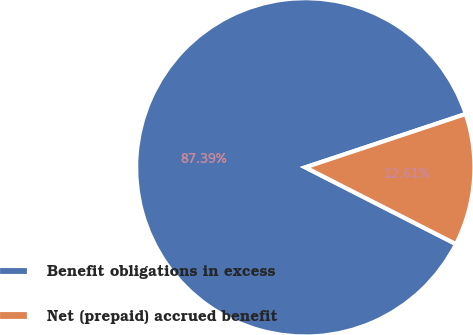Convert chart to OTSL. <chart><loc_0><loc_0><loc_500><loc_500><pie_chart><fcel>Benefit obligations in excess<fcel>Net (prepaid) accrued benefit<nl><fcel>87.39%<fcel>12.61%<nl></chart> 